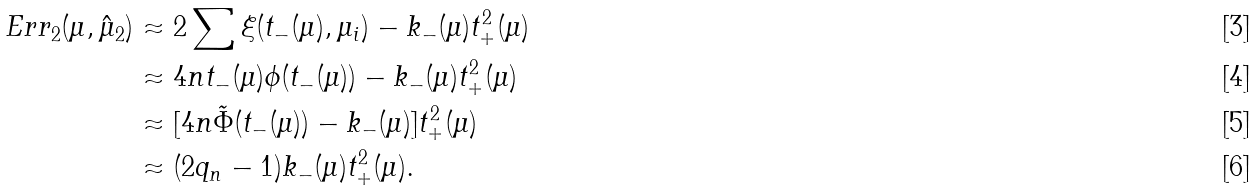<formula> <loc_0><loc_0><loc_500><loc_500>E r r _ { 2 } ( \mu , \hat { \mu } _ { 2 } ) & \approx 2 \sum \xi ( t _ { - } ( \mu ) , \mu _ { i } ) - k _ { - } ( \mu ) t _ { + } ^ { 2 } ( \mu ) \\ & \approx 4 n t _ { - } ( \mu ) \phi ( t _ { - } ( \mu ) ) - k _ { - } ( \mu ) t _ { + } ^ { 2 } ( \mu ) \\ & \approx [ 4 n \tilde { \Phi } ( t _ { - } ( \mu ) ) - k _ { - } ( \mu ) ] t _ { + } ^ { 2 } ( \mu ) \\ & \approx ( 2 q _ { n } - 1 ) k _ { - } ( \mu ) t _ { + } ^ { 2 } ( \mu ) .</formula> 